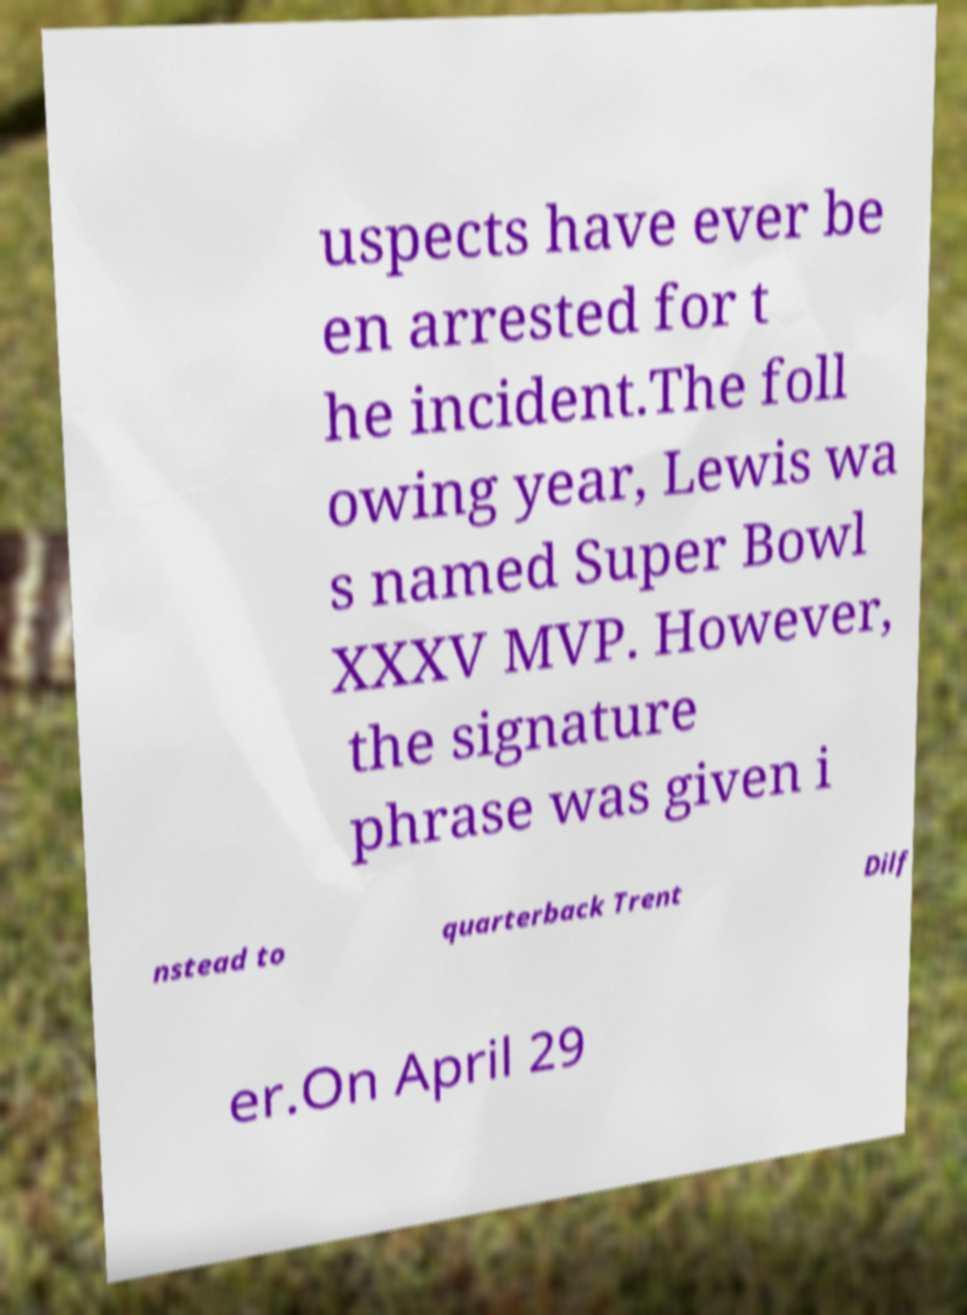Please identify and transcribe the text found in this image. uspects have ever be en arrested for t he incident.The foll owing year, Lewis wa s named Super Bowl XXXV MVP. However, the signature phrase was given i nstead to quarterback Trent Dilf er.On April 29 